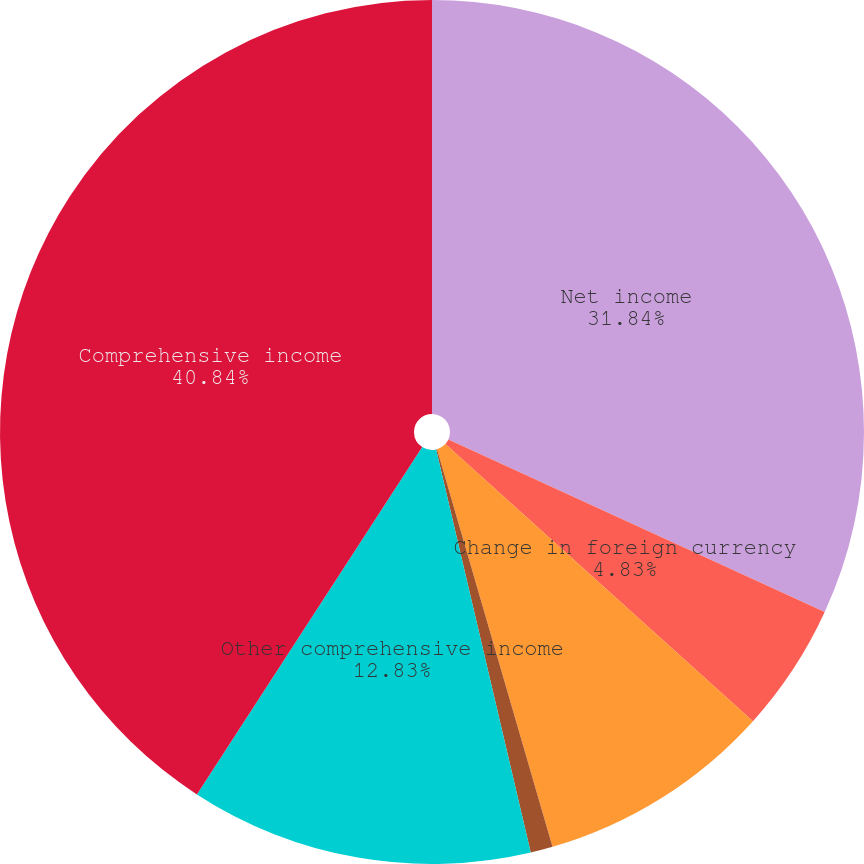<chart> <loc_0><loc_0><loc_500><loc_500><pie_chart><fcel>Net income<fcel>Change in foreign currency<fcel>Deferred gains (losses) net of<fcel>Reclassification adjustment on<fcel>Other comprehensive income<fcel>Comprehensive income<nl><fcel>31.84%<fcel>4.83%<fcel>8.83%<fcel>0.83%<fcel>12.83%<fcel>40.84%<nl></chart> 